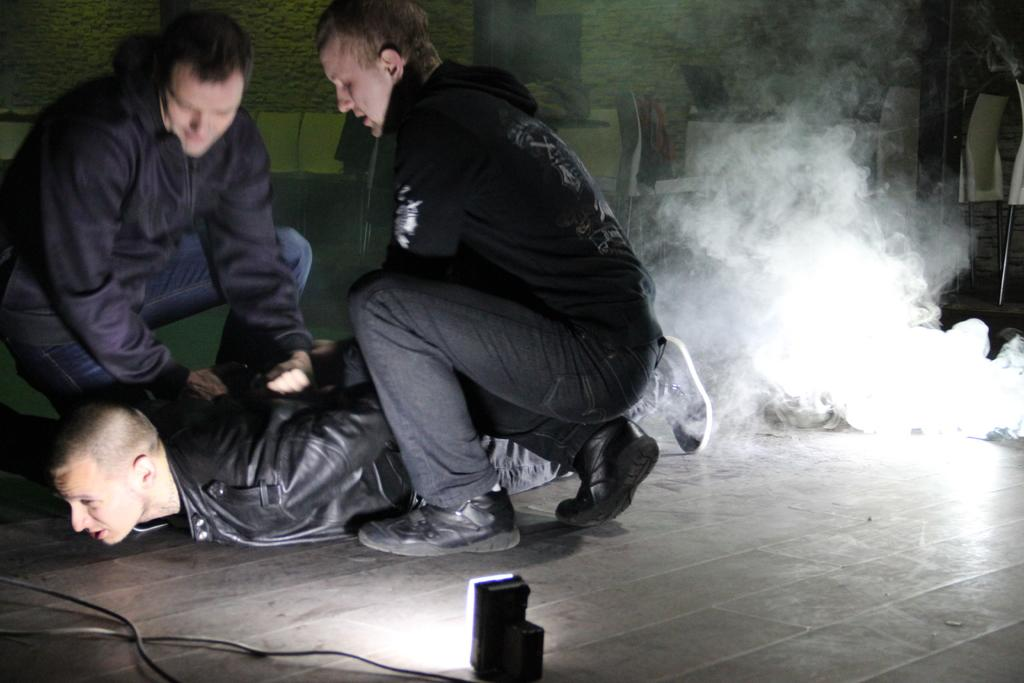What can be seen in the image that indicates a change in the environment? There is smoke in the image, which suggests a change in the environment. What is the source of illumination in the image? There is light in the image, which could be natural or artificial. What type of structure is present in the image? There is a wall in the image, which could be part of a building or a barrier. How many people are in the image? There are three people in the image. What are the people wearing in the image? The three people are wearing black color jackets. Where are the three people located in the image? The three people are on the left side of the image. What type of competition is being held in the image? There is no competition present in the image; it only shows three people wearing black jackets on the left side of the image. What type of punishment is being administered in the image? There is no punishment being administered in the image; it only shows three people wearing black jackets on the left side of the image. 